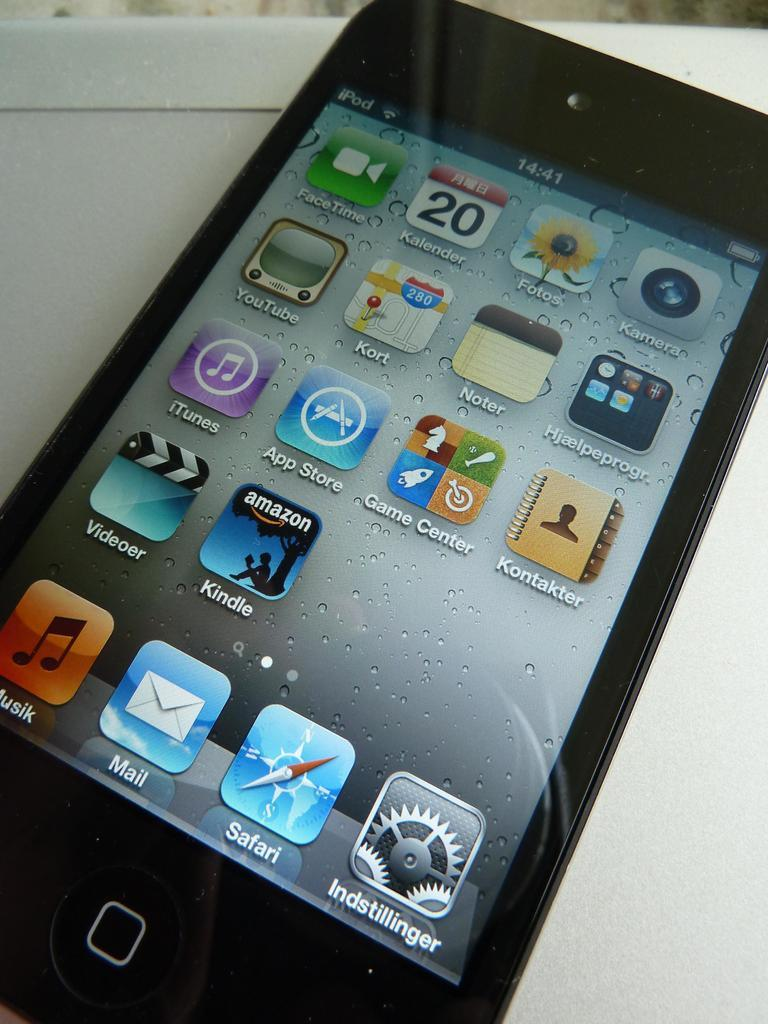<image>
Share a concise interpretation of the image provided. A iPod on a white table with the screen on its home screen. 